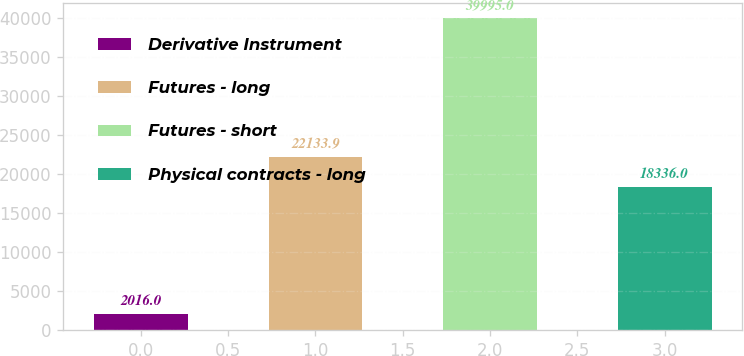Convert chart to OTSL. <chart><loc_0><loc_0><loc_500><loc_500><bar_chart><fcel>Derivative Instrument<fcel>Futures - long<fcel>Futures - short<fcel>Physical contracts - long<nl><fcel>2016<fcel>22133.9<fcel>39995<fcel>18336<nl></chart> 